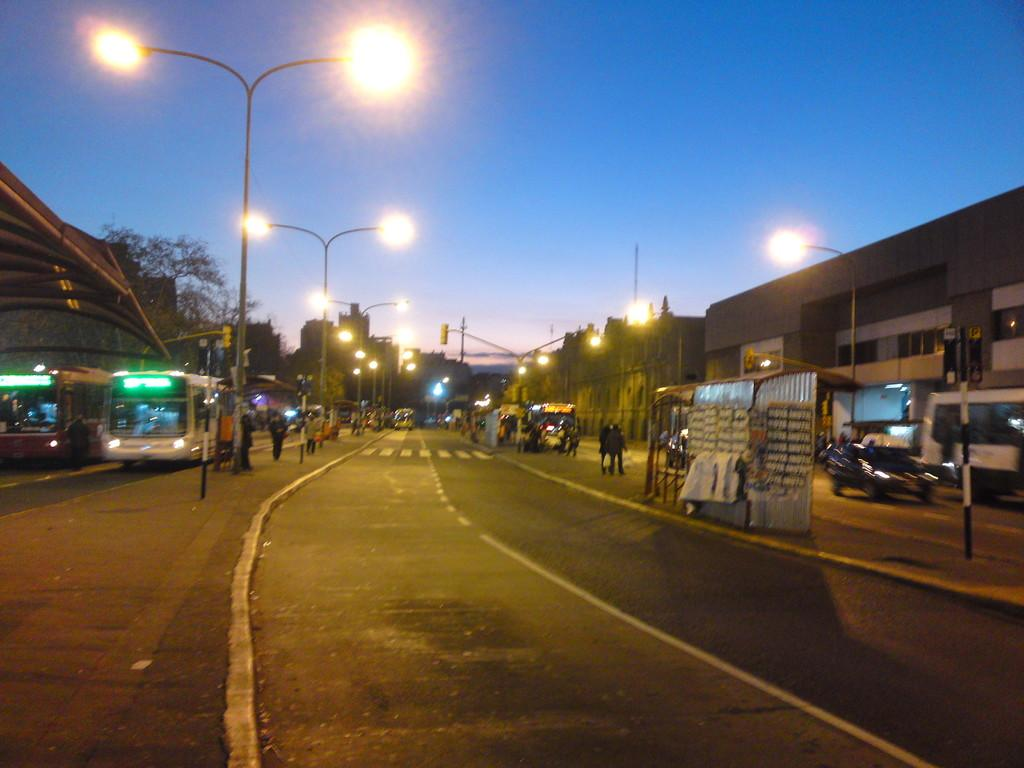What can be seen moving on the roads in the image? There are vehicles on the roads in the image. What can be seen on the footpaths in the image? There are people on footpaths in the image. What structures are present in the image that support lights? There are poles in the image that support lights. What type of structures have windows in the image? There are buildings with windows in the image. What type of vegetation is present in the image? There are trees in the image. What is visible in the background of the image? The sky is visible in the background of the image. How many people are sleeping on the footpaths in the image? There is no indication of anyone sleeping on the footpaths in the image. What type of stitch is used to create the buildings in the image? The image is a photograph, not a drawing or embroidery, so there is no stitching involved in creating the buildings. 